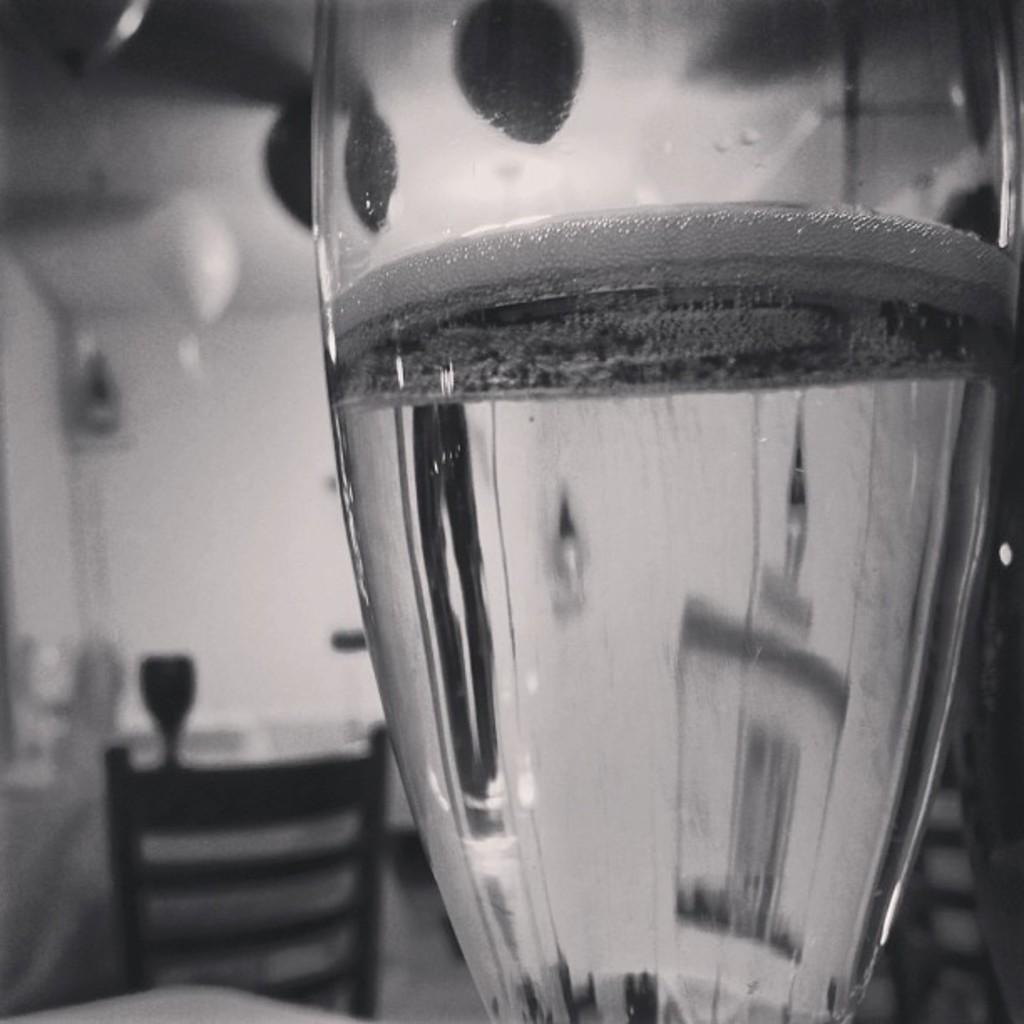What is in the glass that is visible in the image? There is a glass with water in the image. What type of furniture is present in the image? There is a chair in the image. Can you describe any other objects in the image? There are some objects in the image, but their specific details are not mentioned in the provided facts. How would you describe the background of the image? The background of the image is blurry. What type of crime is being committed in the image? There is no indication of any crime being committed in the image; it features a glass with water, a chair, and some other objects. How many lizards can be seen in the image? There are no lizards present in the image. 